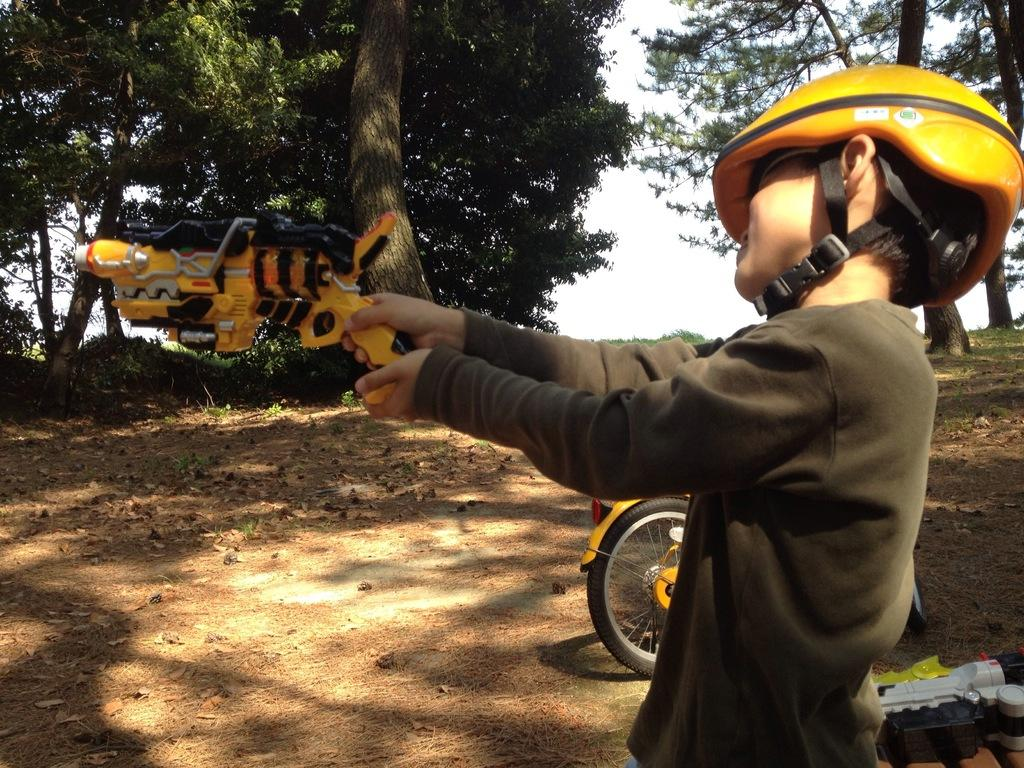Who is present in the image? There is a person in the image. What is the person wearing on their head? The person is wearing a helmet. What is the person holding in their hands? The person is holding a toy in their hands. What can be seen in the background of the image? There is a bicycle, a toy, and trees in the background of the image. What is visible at the bottom of the image? The ground is visible at the bottom of the image. What type of notebook is the person using to write in the image? There is no notebook present in the image. Does the person have a tail in the image? The person does not have a tail in the image. 